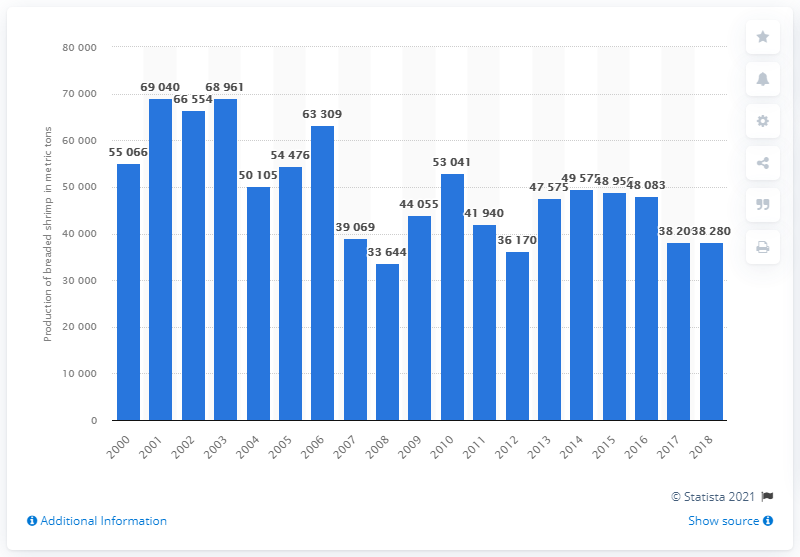Identify some key points in this picture. In 2016, the United States produced a total of 48,083 metric tons of breaded shrimp. 